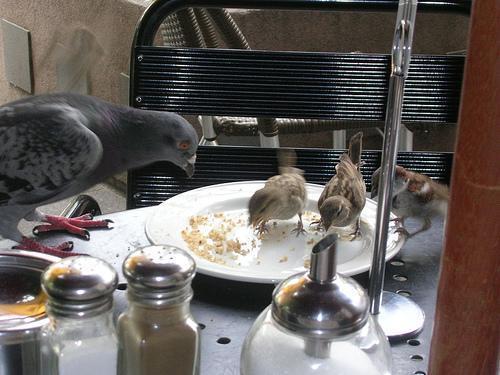How many birds are there?
Give a very brief answer. 4. 